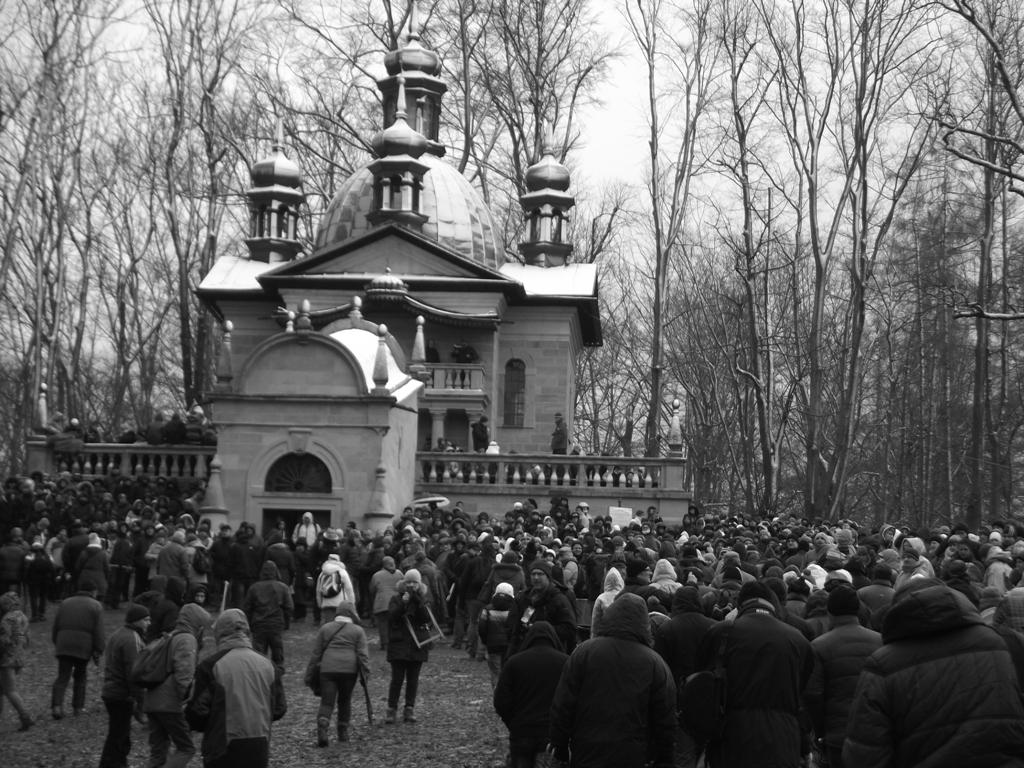What is the color scheme of the image? The image is black and white. How many people are present in the image? There are many people in the image. What can be seen in the background of the image? There is a building, trees, and the sky visible in the background of the image. Can you tell me how many swings are present in the image? There are no swings present in the image; it features a black and white scene with many people and a background that includes a building, trees, and the sky. 